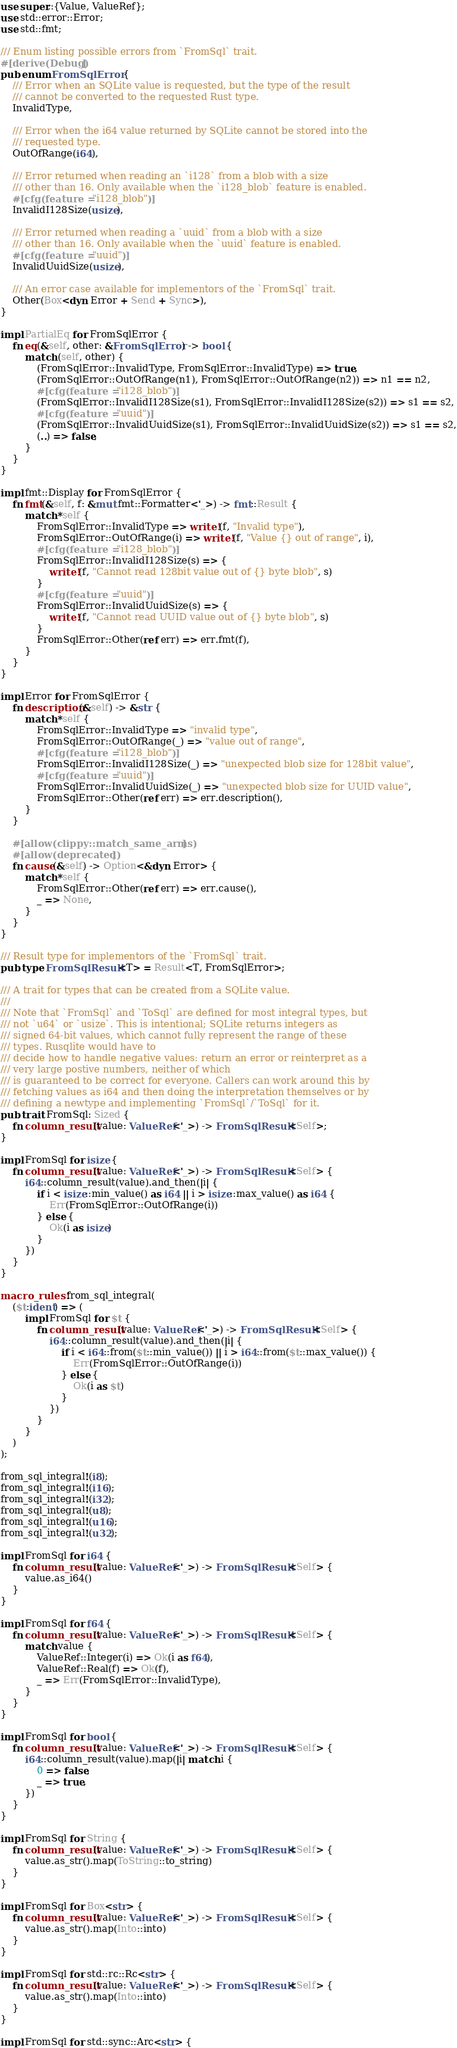Convert code to text. <code><loc_0><loc_0><loc_500><loc_500><_Rust_>use super::{Value, ValueRef};
use std::error::Error;
use std::fmt;

/// Enum listing possible errors from `FromSql` trait.
#[derive(Debug)]
pub enum FromSqlError {
    /// Error when an SQLite value is requested, but the type of the result
    /// cannot be converted to the requested Rust type.
    InvalidType,

    /// Error when the i64 value returned by SQLite cannot be stored into the
    /// requested type.
    OutOfRange(i64),

    /// Error returned when reading an `i128` from a blob with a size
    /// other than 16. Only available when the `i128_blob` feature is enabled.
    #[cfg(feature = "i128_blob")]
    InvalidI128Size(usize),

    /// Error returned when reading a `uuid` from a blob with a size
    /// other than 16. Only available when the `uuid` feature is enabled.
    #[cfg(feature = "uuid")]
    InvalidUuidSize(usize),

    /// An error case available for implementors of the `FromSql` trait.
    Other(Box<dyn Error + Send + Sync>),
}

impl PartialEq for FromSqlError {
    fn eq(&self, other: &FromSqlError) -> bool {
        match (self, other) {
            (FromSqlError::InvalidType, FromSqlError::InvalidType) => true,
            (FromSqlError::OutOfRange(n1), FromSqlError::OutOfRange(n2)) => n1 == n2,
            #[cfg(feature = "i128_blob")]
            (FromSqlError::InvalidI128Size(s1), FromSqlError::InvalidI128Size(s2)) => s1 == s2,
            #[cfg(feature = "uuid")]
            (FromSqlError::InvalidUuidSize(s1), FromSqlError::InvalidUuidSize(s2)) => s1 == s2,
            (..) => false,
        }
    }
}

impl fmt::Display for FromSqlError {
    fn fmt(&self, f: &mut fmt::Formatter<'_>) -> fmt::Result {
        match *self {
            FromSqlError::InvalidType => write!(f, "Invalid type"),
            FromSqlError::OutOfRange(i) => write!(f, "Value {} out of range", i),
            #[cfg(feature = "i128_blob")]
            FromSqlError::InvalidI128Size(s) => {
                write!(f, "Cannot read 128bit value out of {} byte blob", s)
            }
            #[cfg(feature = "uuid")]
            FromSqlError::InvalidUuidSize(s) => {
                write!(f, "Cannot read UUID value out of {} byte blob", s)
            }
            FromSqlError::Other(ref err) => err.fmt(f),
        }
    }
}

impl Error for FromSqlError {
    fn description(&self) -> &str {
        match *self {
            FromSqlError::InvalidType => "invalid type",
            FromSqlError::OutOfRange(_) => "value out of range",
            #[cfg(feature = "i128_blob")]
            FromSqlError::InvalidI128Size(_) => "unexpected blob size for 128bit value",
            #[cfg(feature = "uuid")]
            FromSqlError::InvalidUuidSize(_) => "unexpected blob size for UUID value",
            FromSqlError::Other(ref err) => err.description(),
        }
    }

    #[allow(clippy::match_same_arms)]
    #[allow(deprecated)]
    fn cause(&self) -> Option<&dyn Error> {
        match *self {
            FromSqlError::Other(ref err) => err.cause(),
            _ => None,
        }
    }
}

/// Result type for implementors of the `FromSql` trait.
pub type FromSqlResult<T> = Result<T, FromSqlError>;

/// A trait for types that can be created from a SQLite value.
///
/// Note that `FromSql` and `ToSql` are defined for most integral types, but
/// not `u64` or `usize`. This is intentional; SQLite returns integers as
/// signed 64-bit values, which cannot fully represent the range of these
/// types. Rusqlite would have to
/// decide how to handle negative values: return an error or reinterpret as a
/// very large postive numbers, neither of which
/// is guaranteed to be correct for everyone. Callers can work around this by
/// fetching values as i64 and then doing the interpretation themselves or by
/// defining a newtype and implementing `FromSql`/`ToSql` for it.
pub trait FromSql: Sized {
    fn column_result(value: ValueRef<'_>) -> FromSqlResult<Self>;
}

impl FromSql for isize {
    fn column_result(value: ValueRef<'_>) -> FromSqlResult<Self> {
        i64::column_result(value).and_then(|i| {
            if i < isize::min_value() as i64 || i > isize::max_value() as i64 {
                Err(FromSqlError::OutOfRange(i))
            } else {
                Ok(i as isize)
            }
        })
    }
}

macro_rules! from_sql_integral(
    ($t:ident) => (
        impl FromSql for $t {
            fn column_result(value: ValueRef<'_>) -> FromSqlResult<Self> {
                i64::column_result(value).and_then(|i| {
                    if i < i64::from($t::min_value()) || i > i64::from($t::max_value()) {
                        Err(FromSqlError::OutOfRange(i))
                    } else {
                        Ok(i as $t)
                    }
                })
            }
        }
    )
);

from_sql_integral!(i8);
from_sql_integral!(i16);
from_sql_integral!(i32);
from_sql_integral!(u8);
from_sql_integral!(u16);
from_sql_integral!(u32);

impl FromSql for i64 {
    fn column_result(value: ValueRef<'_>) -> FromSqlResult<Self> {
        value.as_i64()
    }
}

impl FromSql for f64 {
    fn column_result(value: ValueRef<'_>) -> FromSqlResult<Self> {
        match value {
            ValueRef::Integer(i) => Ok(i as f64),
            ValueRef::Real(f) => Ok(f),
            _ => Err(FromSqlError::InvalidType),
        }
    }
}

impl FromSql for bool {
    fn column_result(value: ValueRef<'_>) -> FromSqlResult<Self> {
        i64::column_result(value).map(|i| match i {
            0 => false,
            _ => true,
        })
    }
}

impl FromSql for String {
    fn column_result(value: ValueRef<'_>) -> FromSqlResult<Self> {
        value.as_str().map(ToString::to_string)
    }
}

impl FromSql for Box<str> {
    fn column_result(value: ValueRef<'_>) -> FromSqlResult<Self> {
        value.as_str().map(Into::into)
    }
}

impl FromSql for std::rc::Rc<str> {
    fn column_result(value: ValueRef<'_>) -> FromSqlResult<Self> {
        value.as_str().map(Into::into)
    }
}

impl FromSql for std::sync::Arc<str> {</code> 